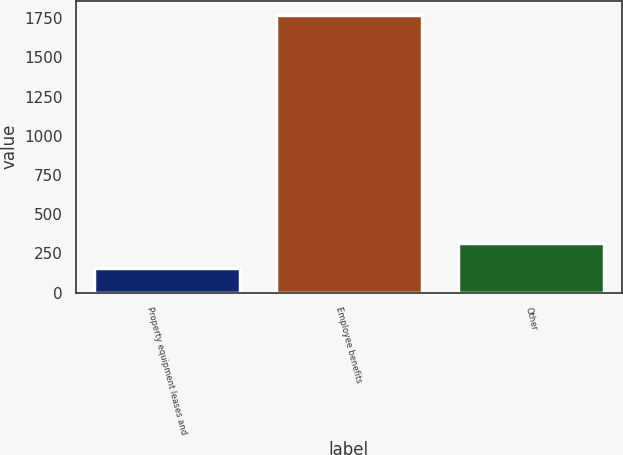Convert chart. <chart><loc_0><loc_0><loc_500><loc_500><bar_chart><fcel>Property equipment leases and<fcel>Employee benefits<fcel>Other<nl><fcel>157<fcel>1771<fcel>318.4<nl></chart> 